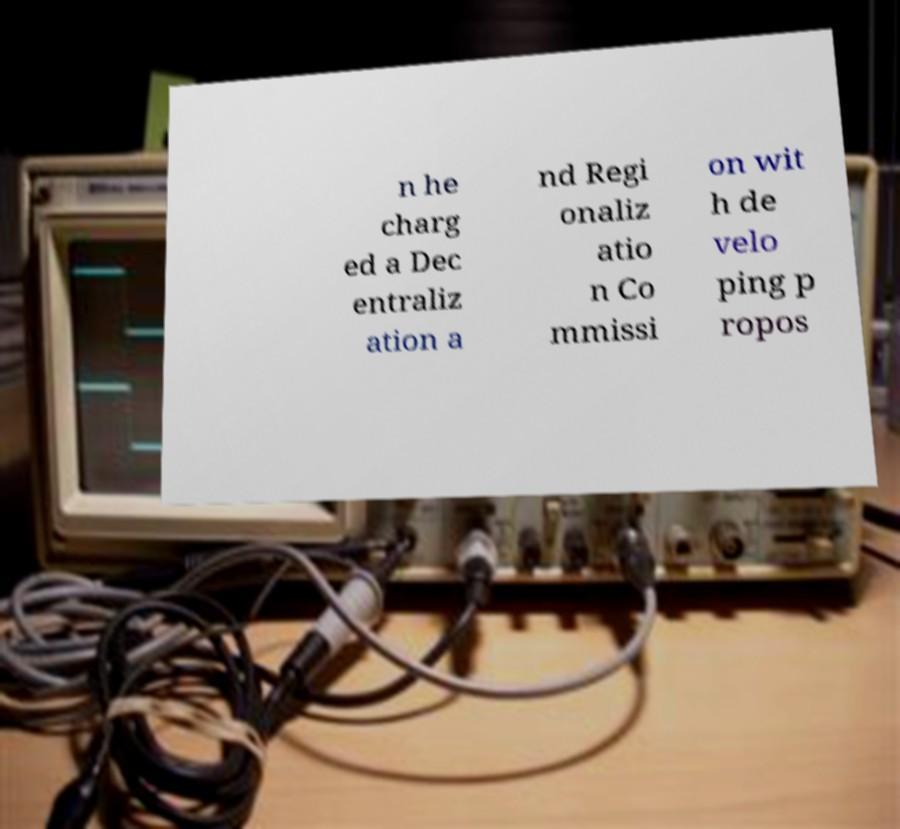There's text embedded in this image that I need extracted. Can you transcribe it verbatim? n he charg ed a Dec entraliz ation a nd Regi onaliz atio n Co mmissi on wit h de velo ping p ropos 